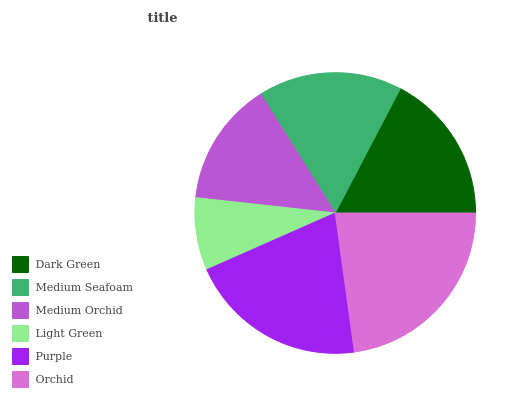Is Light Green the minimum?
Answer yes or no. Yes. Is Orchid the maximum?
Answer yes or no. Yes. Is Medium Seafoam the minimum?
Answer yes or no. No. Is Medium Seafoam the maximum?
Answer yes or no. No. Is Dark Green greater than Medium Seafoam?
Answer yes or no. Yes. Is Medium Seafoam less than Dark Green?
Answer yes or no. Yes. Is Medium Seafoam greater than Dark Green?
Answer yes or no. No. Is Dark Green less than Medium Seafoam?
Answer yes or no. No. Is Dark Green the high median?
Answer yes or no. Yes. Is Medium Seafoam the low median?
Answer yes or no. Yes. Is Orchid the high median?
Answer yes or no. No. Is Purple the low median?
Answer yes or no. No. 